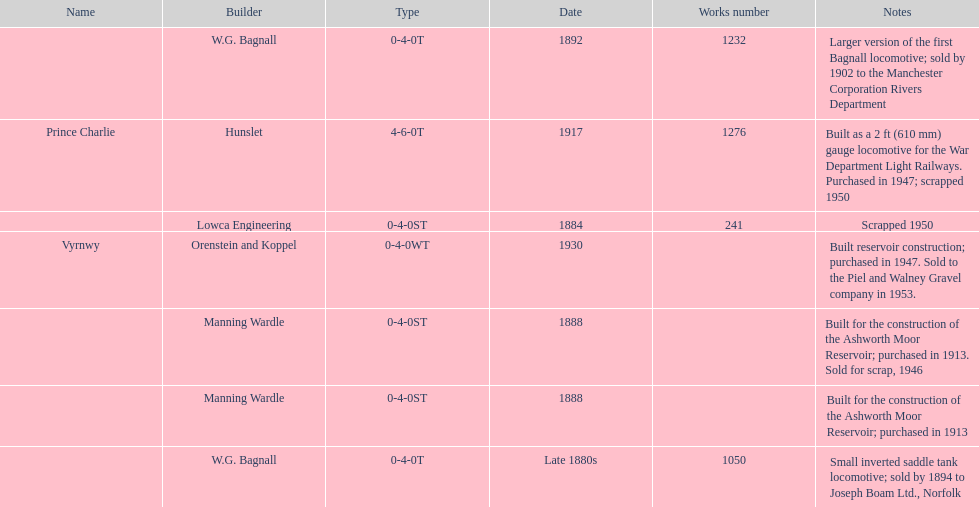Who built the larger version of the first bagnall locomotive? W.G. Bagnall. 